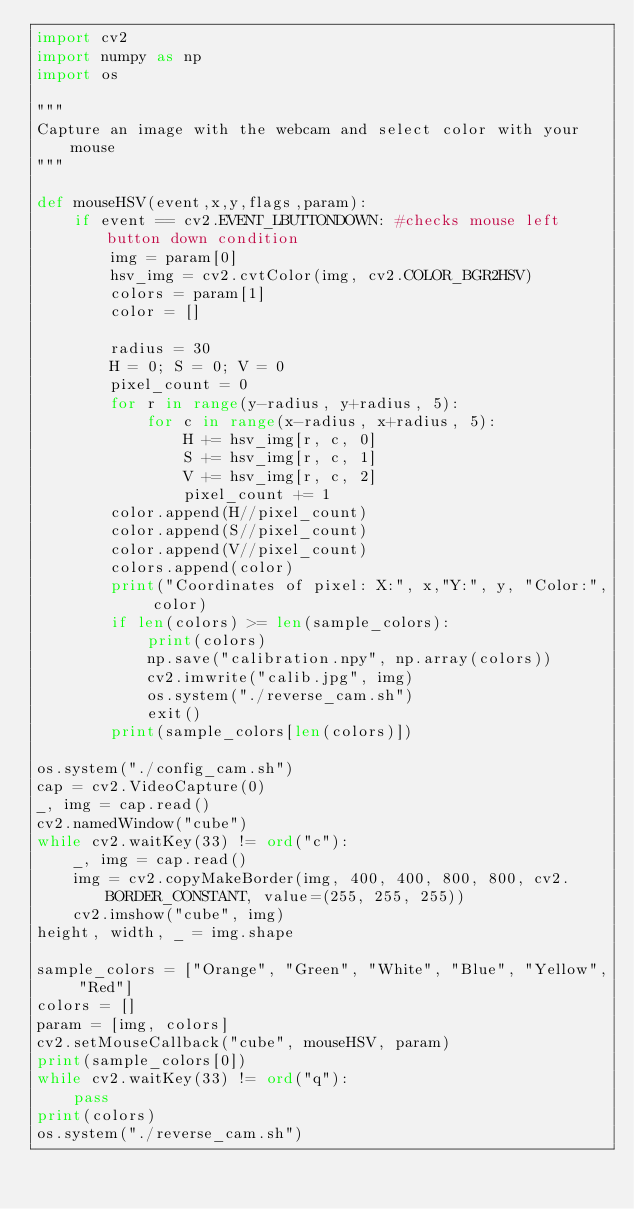<code> <loc_0><loc_0><loc_500><loc_500><_Python_>import cv2
import numpy as np
import os

"""
Capture an image with the webcam and select color with your mouse
"""

def mouseHSV(event,x,y,flags,param):
    if event == cv2.EVENT_LBUTTONDOWN: #checks mouse left button down condition
        img = param[0]
        hsv_img = cv2.cvtColor(img, cv2.COLOR_BGR2HSV)
        colors = param[1]
        color = []
        
        radius = 30
        H = 0; S = 0; V = 0
        pixel_count = 0
        for r in range(y-radius, y+radius, 5):
            for c in range(x-radius, x+radius, 5):
                H += hsv_img[r, c, 0]
                S += hsv_img[r, c, 1]
                V += hsv_img[r, c, 2]
                pixel_count += 1
        color.append(H//pixel_count)
        color.append(S//pixel_count)
        color.append(V//pixel_count)
        colors.append(color)
        print("Coordinates of pixel: X:", x,"Y:", y, "Color:", color)
        if len(colors) >= len(sample_colors):
            print(colors)
            np.save("calibration.npy", np.array(colors))
            cv2.imwrite("calib.jpg", img)
            os.system("./reverse_cam.sh")
            exit()
        print(sample_colors[len(colors)])

os.system("./config_cam.sh")
cap = cv2.VideoCapture(0)
_, img = cap.read()
cv2.namedWindow("cube")
while cv2.waitKey(33) != ord("c"):
    _, img = cap.read()
    img = cv2.copyMakeBorder(img, 400, 400, 800, 800, cv2.BORDER_CONSTANT, value=(255, 255, 255))
    cv2.imshow("cube", img)
height, width, _ = img.shape

sample_colors = ["Orange", "Green", "White", "Blue", "Yellow", "Red"]
colors = []
param = [img, colors]
cv2.setMouseCallback("cube", mouseHSV, param)
print(sample_colors[0])
while cv2.waitKey(33) != ord("q"):
    pass
print(colors)
os.system("./reverse_cam.sh")</code> 